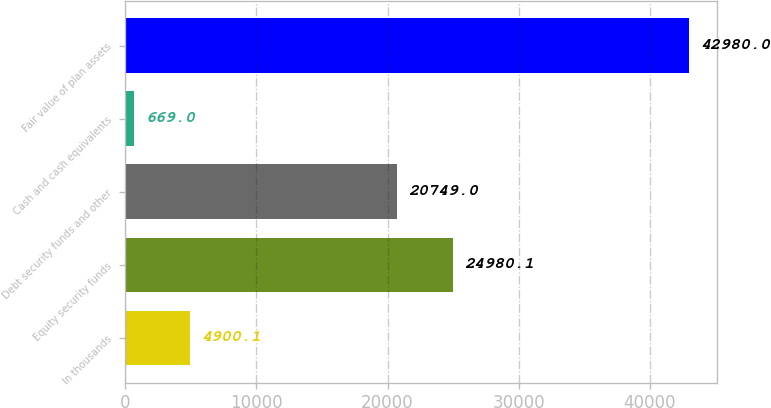Convert chart to OTSL. <chart><loc_0><loc_0><loc_500><loc_500><bar_chart><fcel>In thousands<fcel>Equity security funds<fcel>Debt security funds and other<fcel>Cash and cash equivalents<fcel>Fair value of plan assets<nl><fcel>4900.1<fcel>24980.1<fcel>20749<fcel>669<fcel>42980<nl></chart> 